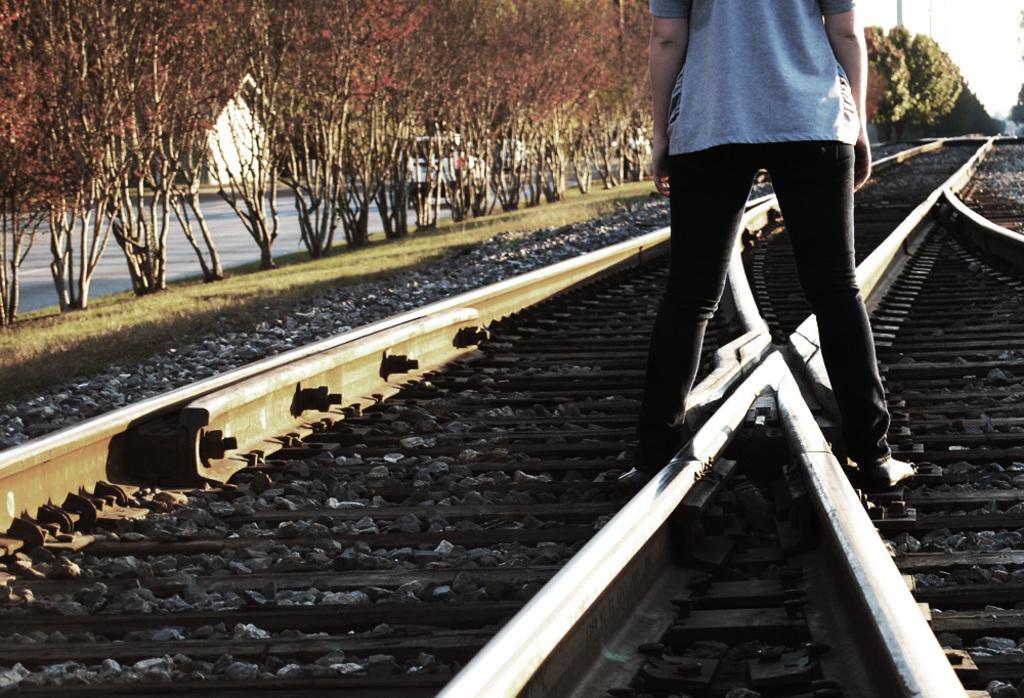Can you describe this image briefly? In the foreground of this image, there is a person standing on the track. On the left, there are trees and the road. At the top, there is the sky. 